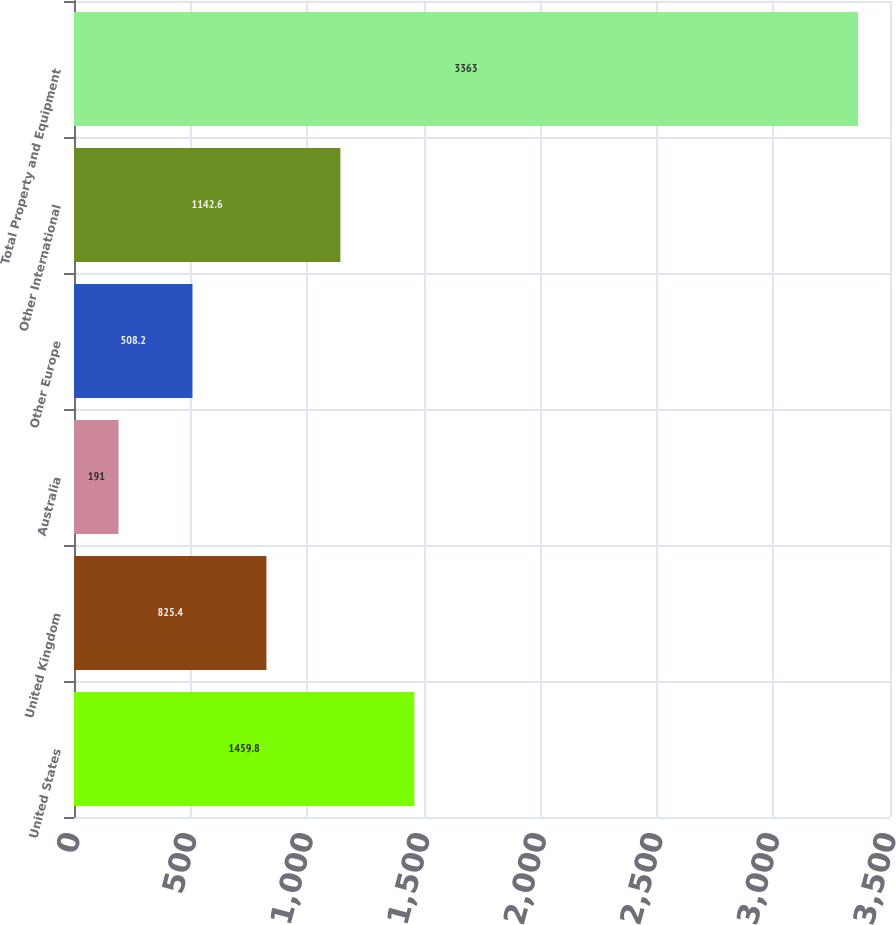Convert chart to OTSL. <chart><loc_0><loc_0><loc_500><loc_500><bar_chart><fcel>United States<fcel>United Kingdom<fcel>Australia<fcel>Other Europe<fcel>Other International<fcel>Total Property and Equipment<nl><fcel>1459.8<fcel>825.4<fcel>191<fcel>508.2<fcel>1142.6<fcel>3363<nl></chart> 